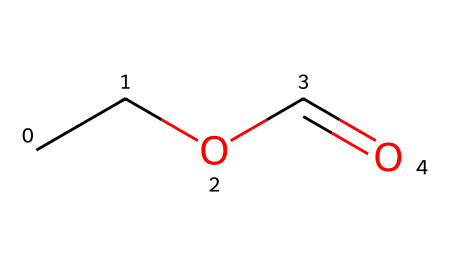What is the name of this chemical? The SMILES representation CC(=O)C suggests that this compound consists of a carbon chain with a carbonyl group, classifying it as an ester, specifically ethyl formate.
Answer: ethyl formate How many carbon atoms are in ethyl formate? Analyzing the SMILES CC(=O)C, we see that there are two carbon atoms in the ethyl group and one in the carbonyl group, totaling three carbon atoms.
Answer: 3 What type of functional group does ethyl formate contain? The carbonyl (=O) and the alkoxy (CC) part of the structure indicate that the functional group present is an ester.
Answer: ester What is the molecular formula of ethyl formate? By counting the atoms in the SMILES representation, there are 3 carbon atoms, 6 hydrogen atoms, and 2 oxygen atoms, which gives the molecular formula C3H6O2.
Answer: C3H6O2 Which part of the molecule contributes to the rum-like odor? The ethyl group in conjunction with the carbonyl group (part of the ester structure) is responsible for the characteristic rum-like odor noted in ethyl formate.
Answer: ethyl group What is the total number of bonds in ethyl formate? The structure has 3 single bonds connecting each of the carbon atoms (C-C and C-O) and 1 double bond (C=O), resulting in a total of 4 bonds.
Answer: 4 